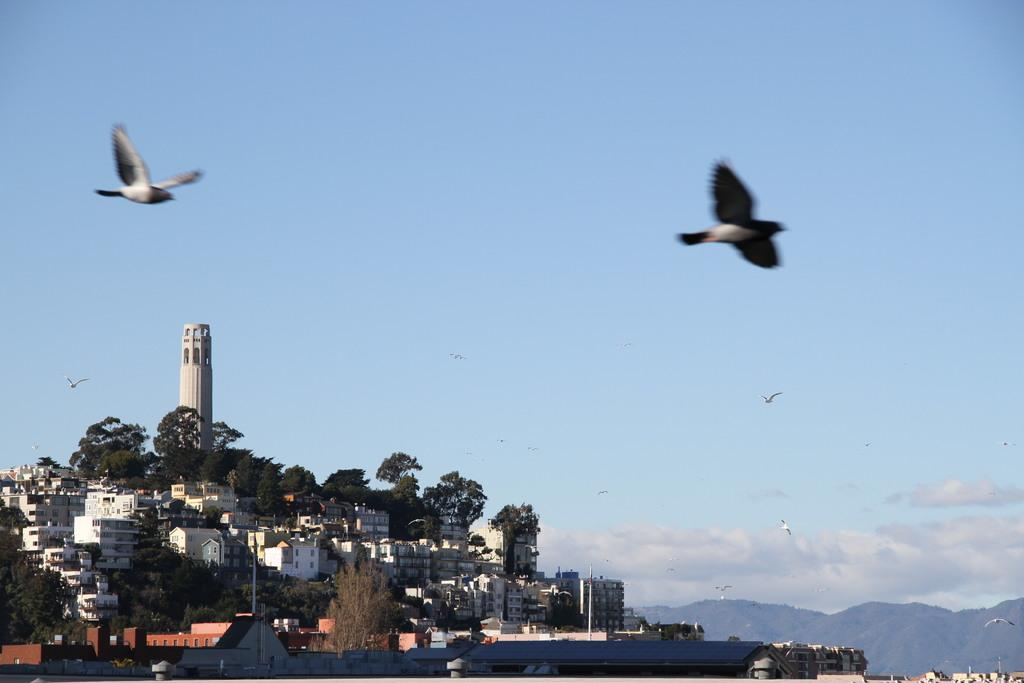What is happening in the image involving animals? There are birds flying in the image. What type of structures can be seen in the image? There are buildings, a tower, and poles in the image. What natural elements are present in the image? There are trees and mountains in the image. What is visible in the background of the image? The sky with clouds is visible in the background of the image. What type of brick material can be seen in the image? There is no brick material present in the image. What type of glass object can be seen in the image? There is no glass object present in the image. 